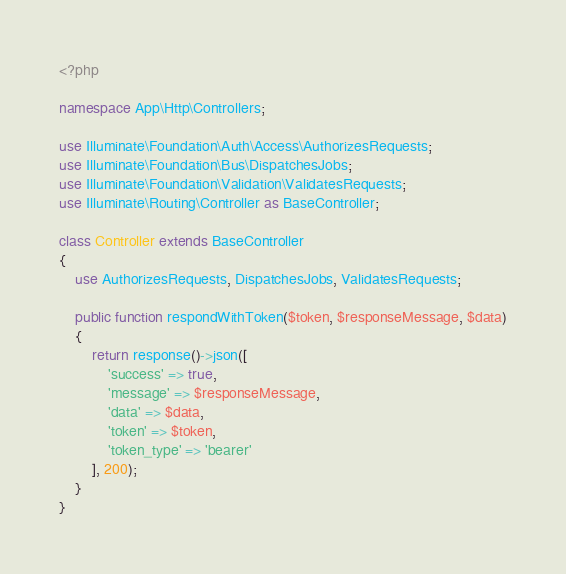<code> <loc_0><loc_0><loc_500><loc_500><_PHP_><?php

namespace App\Http\Controllers;

use Illuminate\Foundation\Auth\Access\AuthorizesRequests;
use Illuminate\Foundation\Bus\DispatchesJobs;
use Illuminate\Foundation\Validation\ValidatesRequests;
use Illuminate\Routing\Controller as BaseController;

class Controller extends BaseController
{
    use AuthorizesRequests, DispatchesJobs, ValidatesRequests;

    public function respondWithToken($token, $responseMessage, $data)
    {
        return response()->json([
            'success' => true,
            'message' => $responseMessage,
            'data' => $data,
            'token' => $token,
            'token_type' => 'bearer'
        ], 200);
    }
}
</code> 